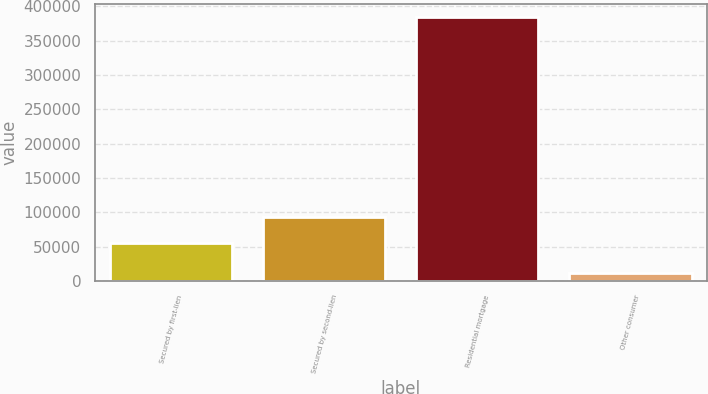<chart> <loc_0><loc_0><loc_500><loc_500><bar_chart><fcel>Secured by first-lien<fcel>Secured by second-lien<fcel>Residential mortgage<fcel>Other consumer<nl><fcel>55341<fcel>92691.5<fcel>384650<fcel>11145<nl></chart> 